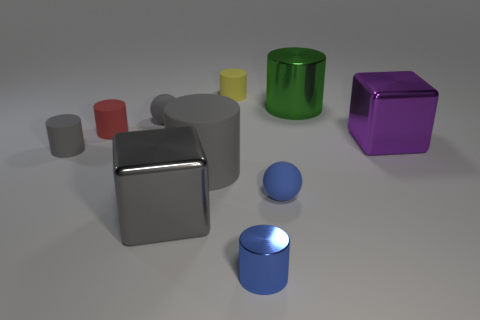What material is the blue thing that is the same shape as the red thing?
Keep it short and to the point. Metal. How many cubes are both behind the big gray block and to the left of the small blue metal cylinder?
Offer a terse response. 0. There is a red cylinder that is behind the large gray shiny thing; how big is it?
Provide a succinct answer. Small. How many other things are the same color as the large metal cylinder?
Offer a very short reply. 0. The large cylinder that is behind the large cube that is on the right side of the yellow cylinder is made of what material?
Offer a very short reply. Metal. Does the tiny sphere to the left of the blue matte thing have the same color as the tiny metallic cylinder?
Your answer should be very brief. No. Is there any other thing that is made of the same material as the purple object?
Ensure brevity in your answer.  Yes. How many purple objects have the same shape as the green thing?
Your answer should be compact. 0. There is a blue cylinder that is the same material as the large green cylinder; what size is it?
Provide a short and direct response. Small. There is a metallic thing that is behind the rubber ball on the left side of the large gray block; are there any large gray matte objects to the right of it?
Provide a short and direct response. No. 